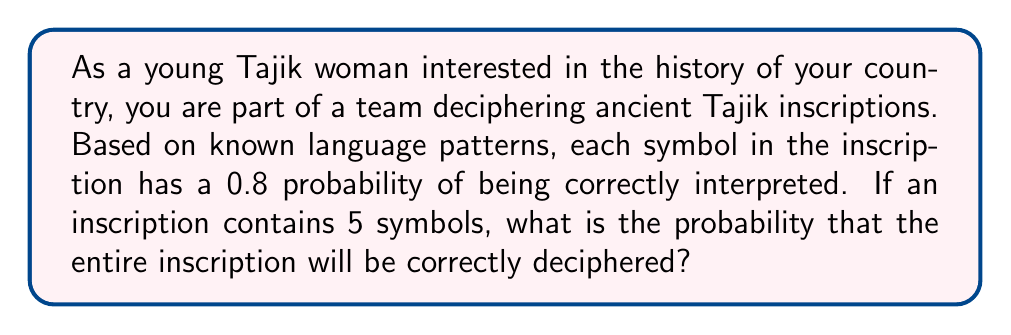Show me your answer to this math problem. To solve this problem, we need to consider the following:

1. Each symbol is independently deciphered with a probability of 0.8.
2. For the entire inscription to be correctly deciphered, all 5 symbols must be correctly interpreted.
3. This scenario follows the multiplication rule of probability for independent events.

Let's approach this step-by-step:

1. Probability of correctly deciphering one symbol: $p = 0.8$

2. We need all 5 symbols to be correct, so we multiply the probability 5 times:

   $P(\text{all correct}) = p^5 = 0.8^5$

3. Calculate $0.8^5$:
   
   $0.8^5 = 0.8 \times 0.8 \times 0.8 \times 0.8 \times 0.8 = 0.32768$

Therefore, the probability of correctly deciphering the entire 5-symbol inscription is approximately 0.32768 or 32.768%.

This can also be written as:

$$P(\text{all correct}) = 0.8^5 = \frac{32768}{100000} \approx 0.32768$$
Answer: $0.32768$ or $32.768\%$ 